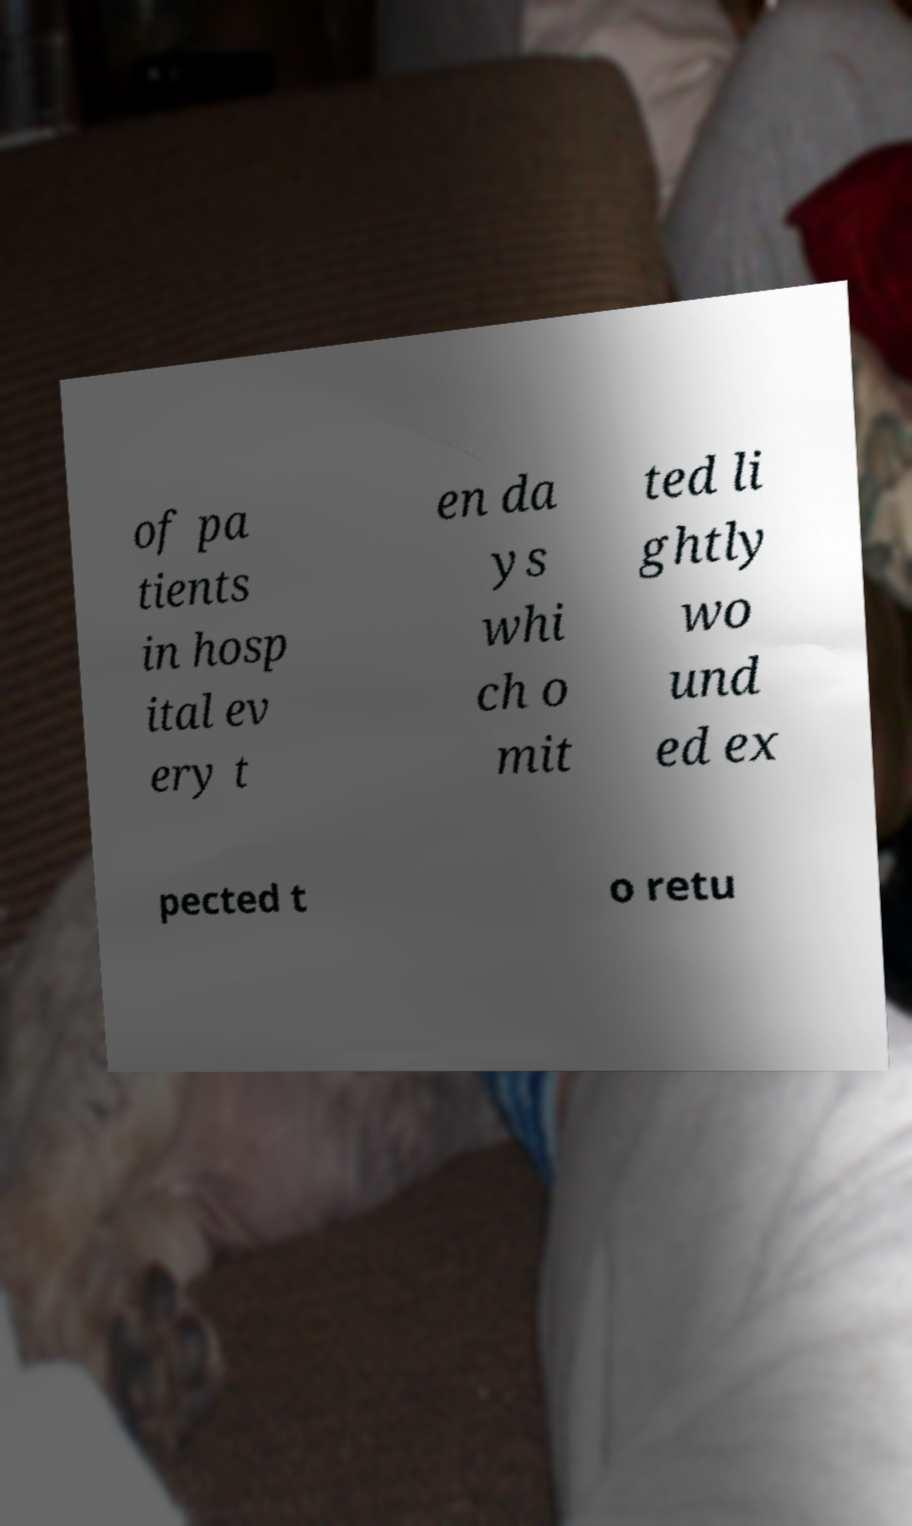Can you read and provide the text displayed in the image?This photo seems to have some interesting text. Can you extract and type it out for me? of pa tients in hosp ital ev ery t en da ys whi ch o mit ted li ghtly wo und ed ex pected t o retu 